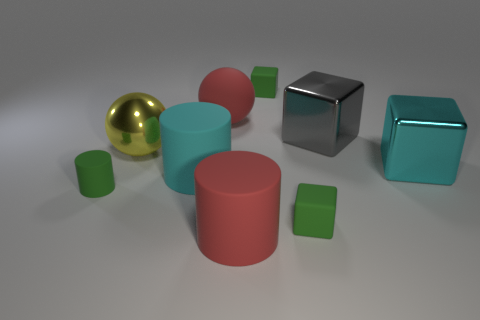Are there any large things to the left of the big red ball?
Provide a succinct answer. Yes. What color is the block that is both in front of the big yellow sphere and to the left of the gray metal cube?
Ensure brevity in your answer.  Green. Are there any small cylinders that have the same color as the big matte sphere?
Keep it short and to the point. No. Are the large cyan block in front of the large yellow metal object and the red object that is in front of the big red sphere made of the same material?
Offer a very short reply. No. There is a red thing in front of the gray metal object; how big is it?
Provide a succinct answer. Large. What is the size of the gray thing?
Give a very brief answer. Large. What is the size of the shiny object that is behind the big metallic object that is on the left side of the large cyan object on the left side of the large red sphere?
Your answer should be very brief. Large. Are there any large gray cylinders made of the same material as the yellow sphere?
Ensure brevity in your answer.  No. What shape is the cyan shiny object?
Make the answer very short. Cube. There is a small cylinder that is made of the same material as the red ball; what color is it?
Provide a short and direct response. Green. 